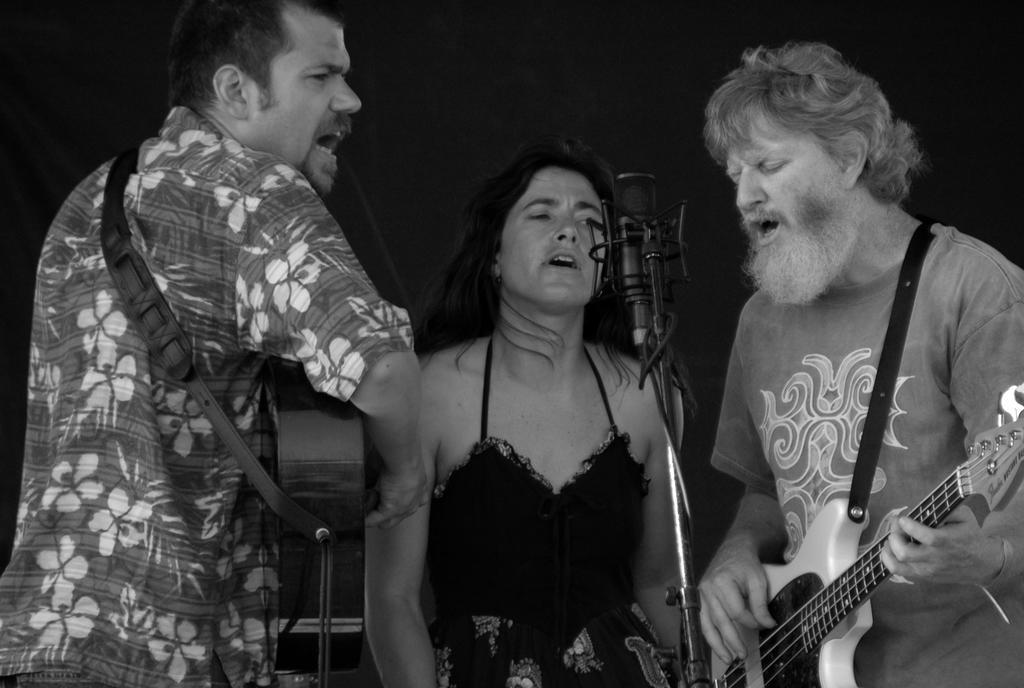Can you describe this image briefly? As we can see in the image, there there are three people standing in the front and the three are singing a song on mike. The person on the left and the person on the right are holding guitars in their hands. 